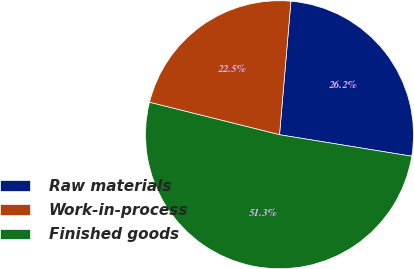Convert chart. <chart><loc_0><loc_0><loc_500><loc_500><pie_chart><fcel>Raw materials<fcel>Work-in-process<fcel>Finished goods<nl><fcel>26.21%<fcel>22.47%<fcel>51.33%<nl></chart> 